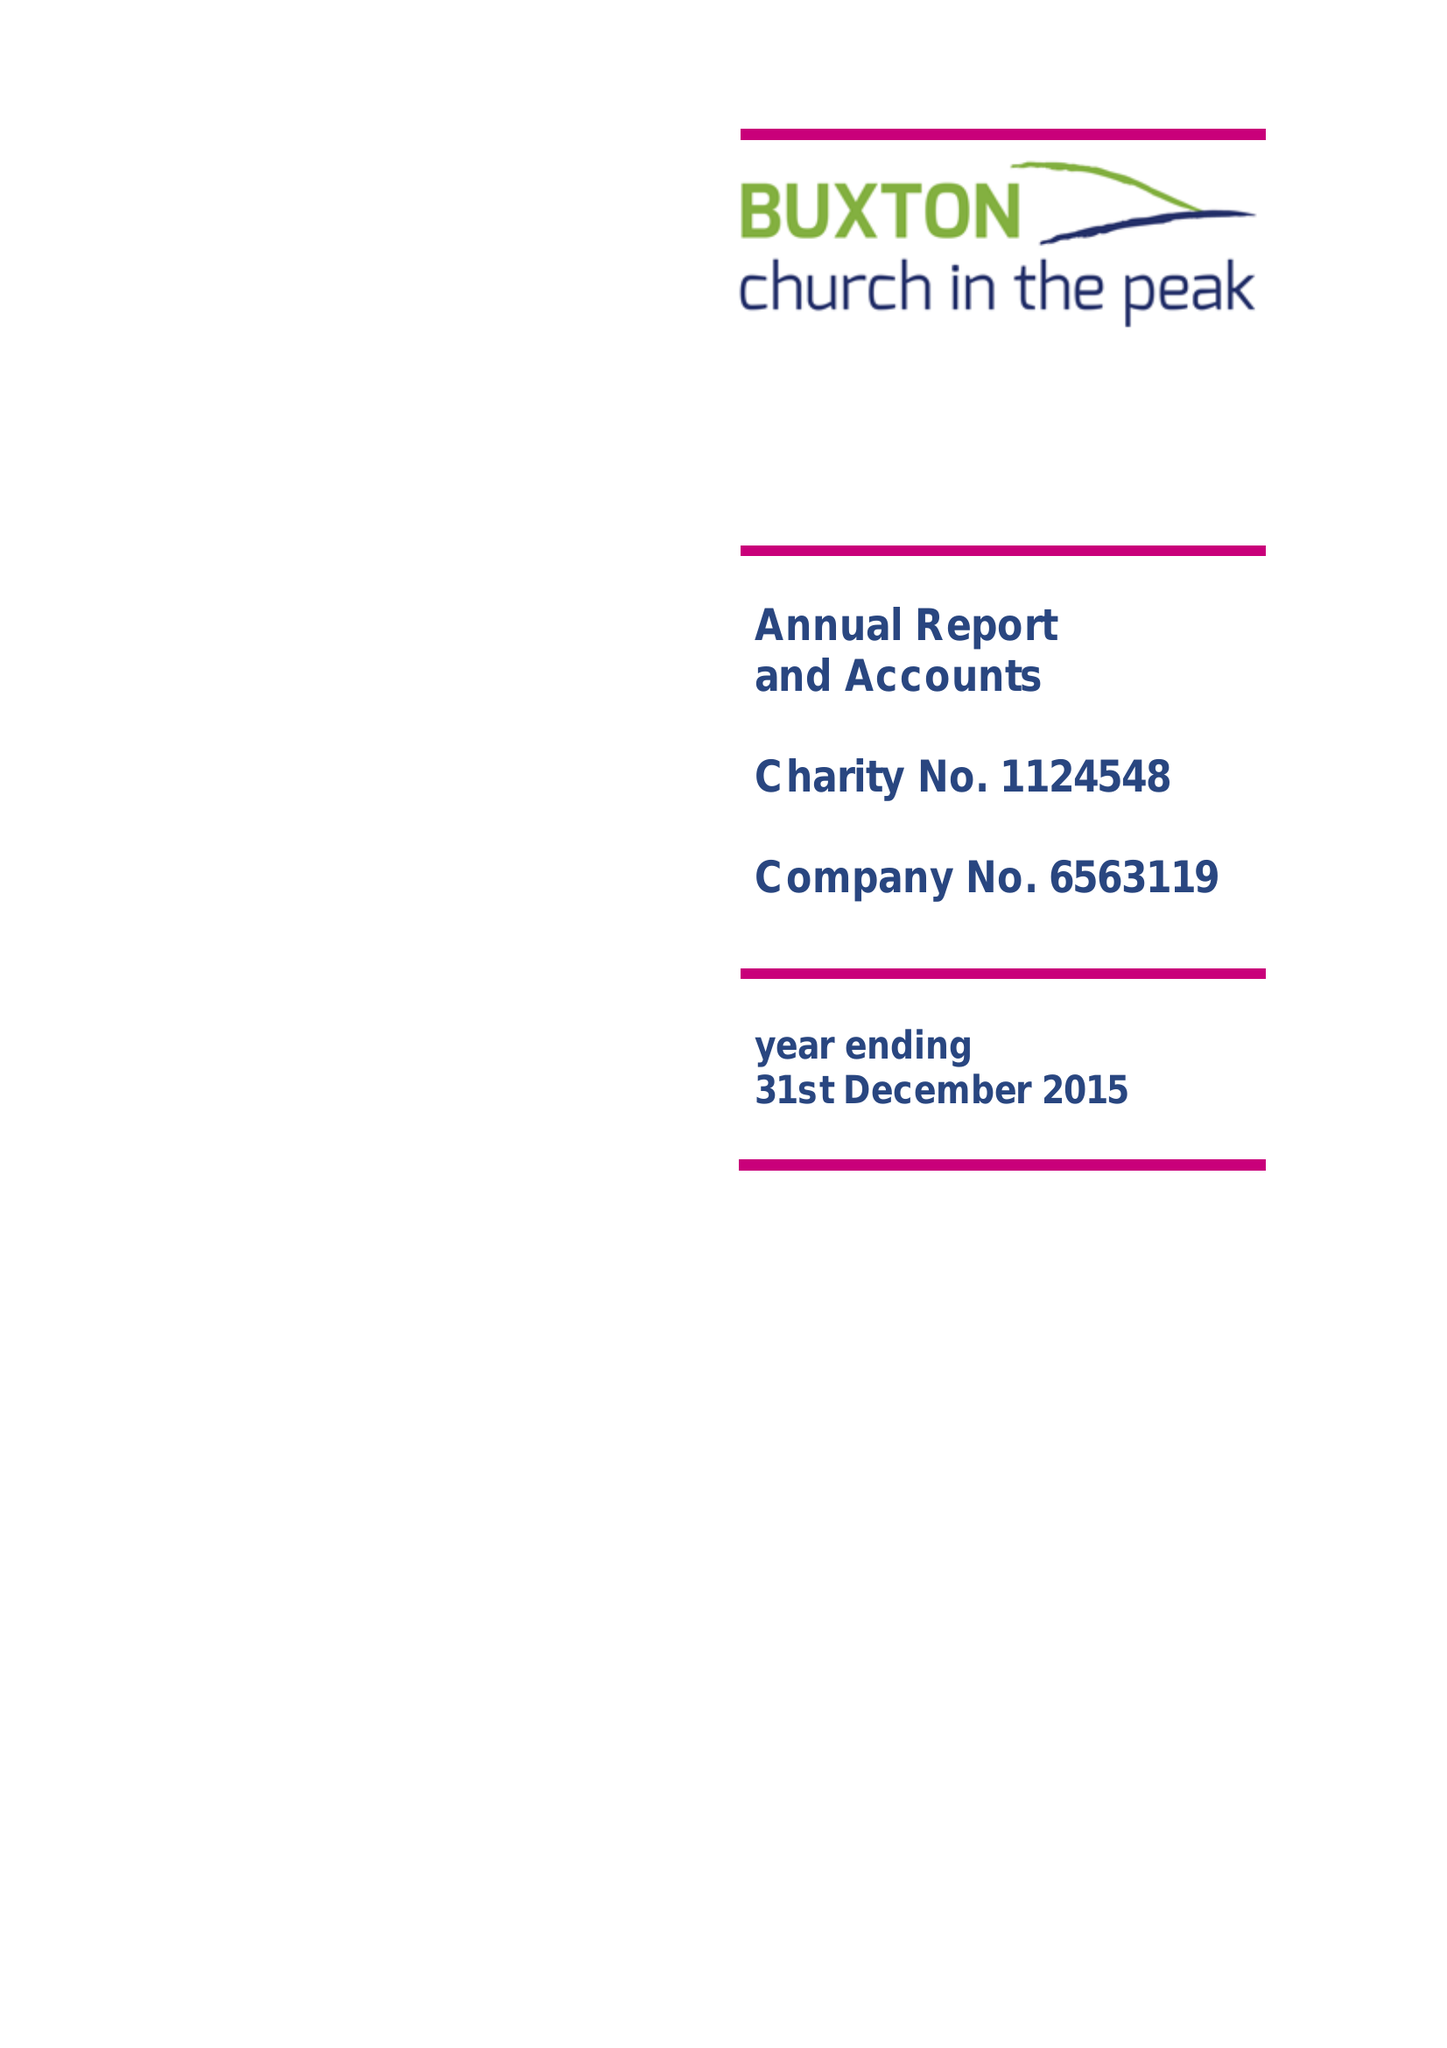What is the value for the charity_name?
Answer the question using a single word or phrase. Buxton Church In The Peak 